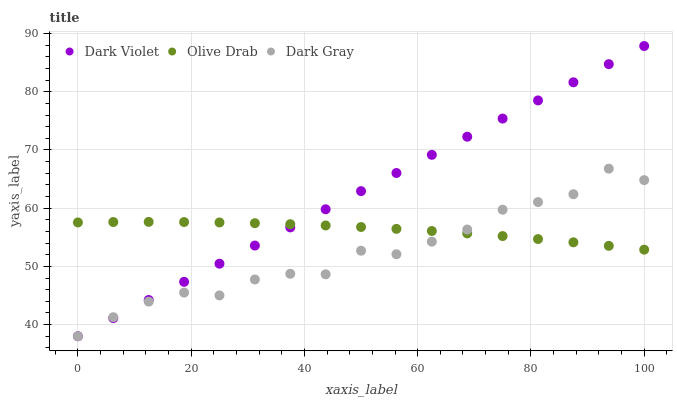Does Dark Gray have the minimum area under the curve?
Answer yes or no. Yes. Does Dark Violet have the maximum area under the curve?
Answer yes or no. Yes. Does Olive Drab have the minimum area under the curve?
Answer yes or no. No. Does Olive Drab have the maximum area under the curve?
Answer yes or no. No. Is Dark Violet the smoothest?
Answer yes or no. Yes. Is Dark Gray the roughest?
Answer yes or no. Yes. Is Olive Drab the smoothest?
Answer yes or no. No. Is Olive Drab the roughest?
Answer yes or no. No. Does Dark Gray have the lowest value?
Answer yes or no. Yes. Does Olive Drab have the lowest value?
Answer yes or no. No. Does Dark Violet have the highest value?
Answer yes or no. Yes. Does Olive Drab have the highest value?
Answer yes or no. No. Does Dark Gray intersect Dark Violet?
Answer yes or no. Yes. Is Dark Gray less than Dark Violet?
Answer yes or no. No. Is Dark Gray greater than Dark Violet?
Answer yes or no. No. 